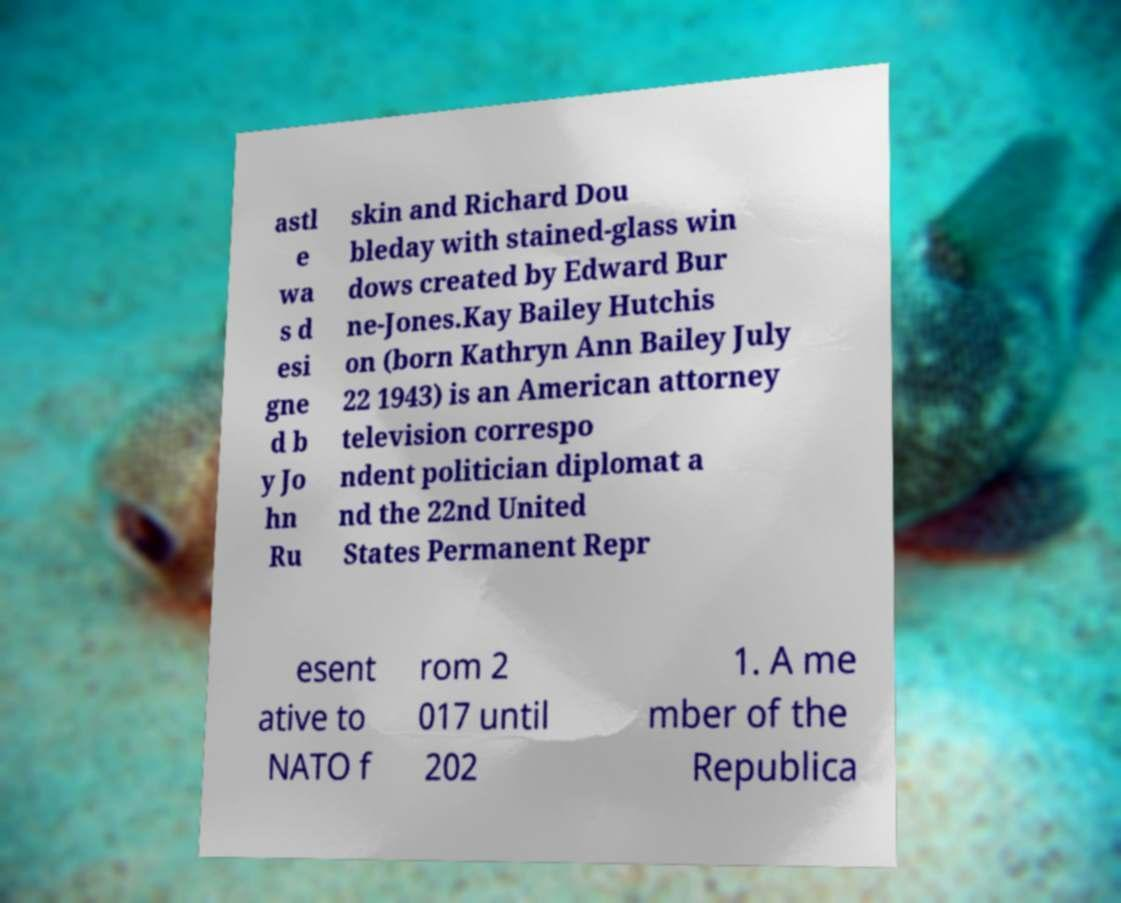Please identify and transcribe the text found in this image. astl e wa s d esi gne d b y Jo hn Ru skin and Richard Dou bleday with stained-glass win dows created by Edward Bur ne-Jones.Kay Bailey Hutchis on (born Kathryn Ann Bailey July 22 1943) is an American attorney television correspo ndent politician diplomat a nd the 22nd United States Permanent Repr esent ative to NATO f rom 2 017 until 202 1. A me mber of the Republica 